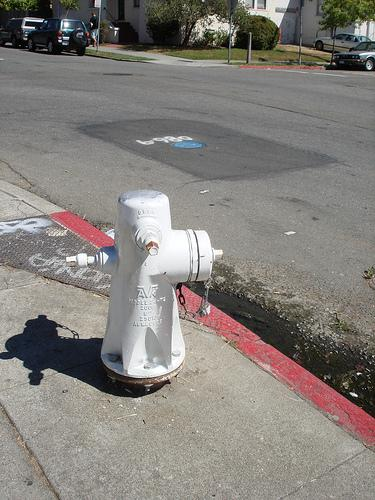Question: why is it bright outside?
Choices:
A. Because the sun is out.
B. There is no shade.
C. It is midday.
D. There are no clouds.
Answer with the letter. Answer: A Question: how big is the fire hydrant?
Choices:
A. About one foot tall.
B. About three feet tall.
C. About two feet tall.
D. About four feet tall.
Answer with the letter. Answer: C Question: who is walking in the background?
Choices:
A. A woman in yellow.
B. A child in pink.
C. A man in blue.
D. A man in black.
Answer with the letter. Answer: D Question: what is next to the man in black?
Choices:
A. A dark sports car.
B. A dark SUV.
C. A light convertible.
D. A light truck.
Answer with the letter. Answer: B 